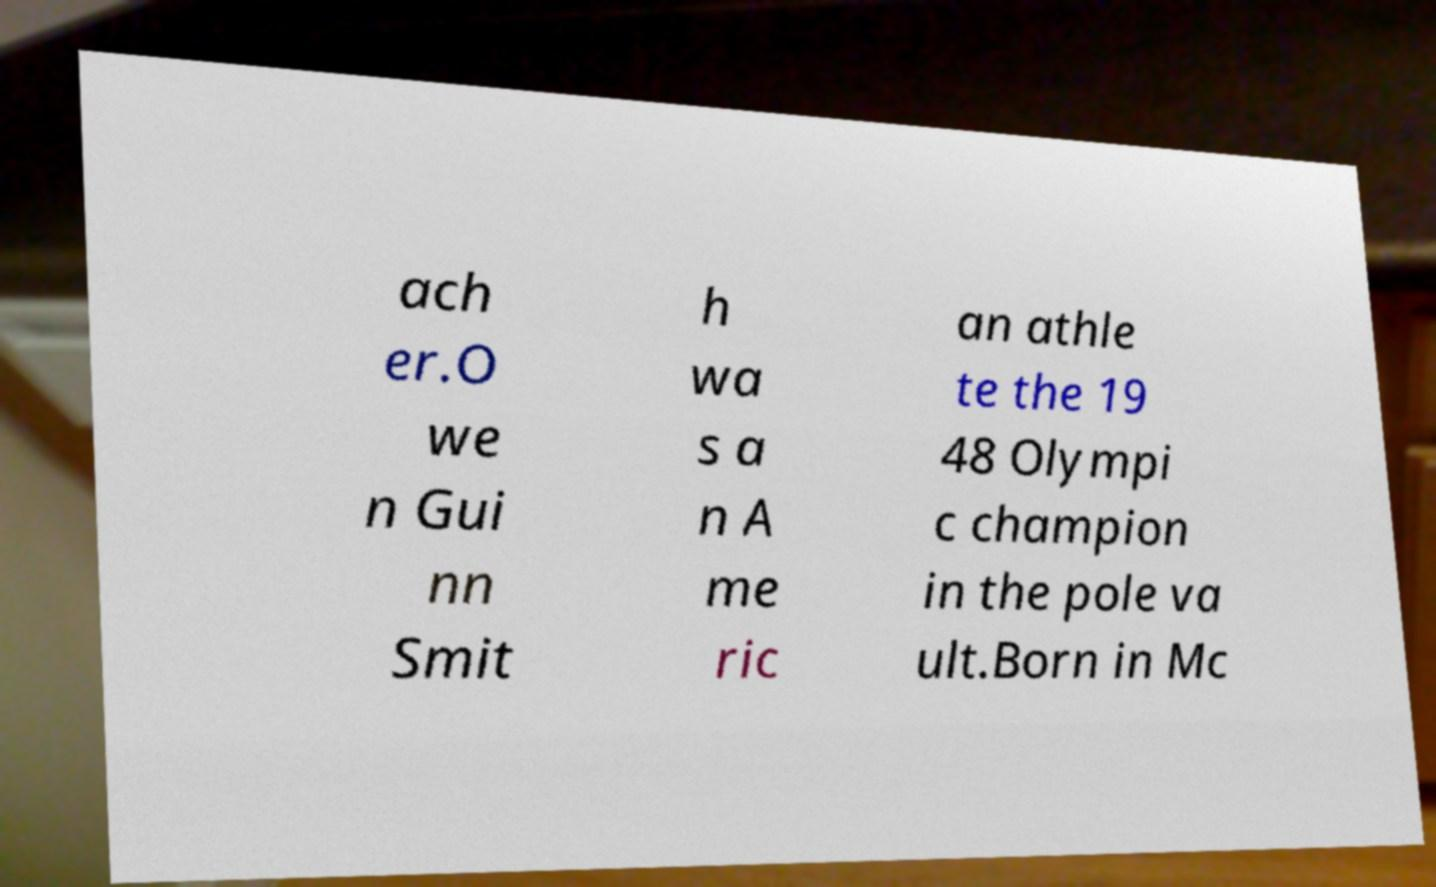Can you read and provide the text displayed in the image?This photo seems to have some interesting text. Can you extract and type it out for me? ach er.O we n Gui nn Smit h wa s a n A me ric an athle te the 19 48 Olympi c champion in the pole va ult.Born in Mc 